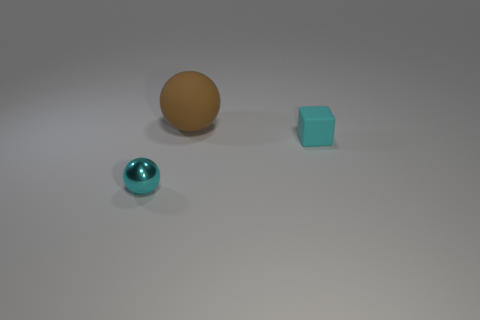Add 3 big spheres. How many objects exist? 6 Subtract all spheres. How many objects are left? 1 Add 2 cyan blocks. How many cyan blocks are left? 3 Add 1 big red cylinders. How many big red cylinders exist? 1 Subtract 0 green cylinders. How many objects are left? 3 Subtract all green matte cylinders. Subtract all cyan objects. How many objects are left? 1 